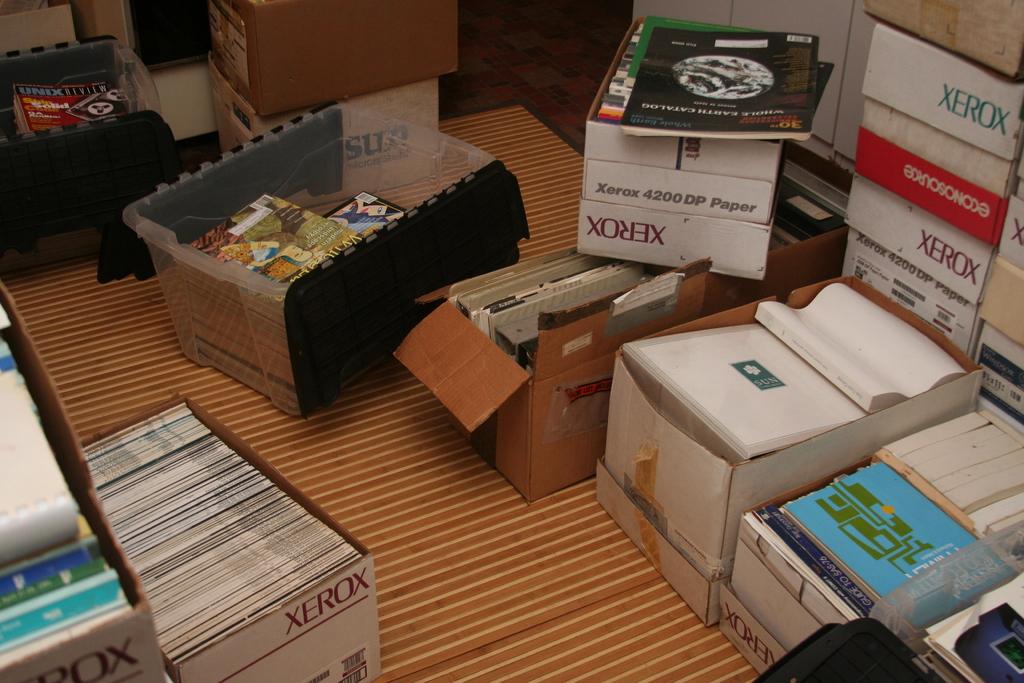Who makes the boxes?
Provide a succinct answer. Xerox. Does the magazine on the top left of the photo say "unix"?
Your response must be concise. Yes. 